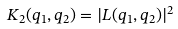Convert formula to latex. <formula><loc_0><loc_0><loc_500><loc_500>K _ { 2 } ( q _ { 1 } , q _ { 2 } ) = | L ( q _ { 1 } , q _ { 2 } ) | ^ { 2 }</formula> 